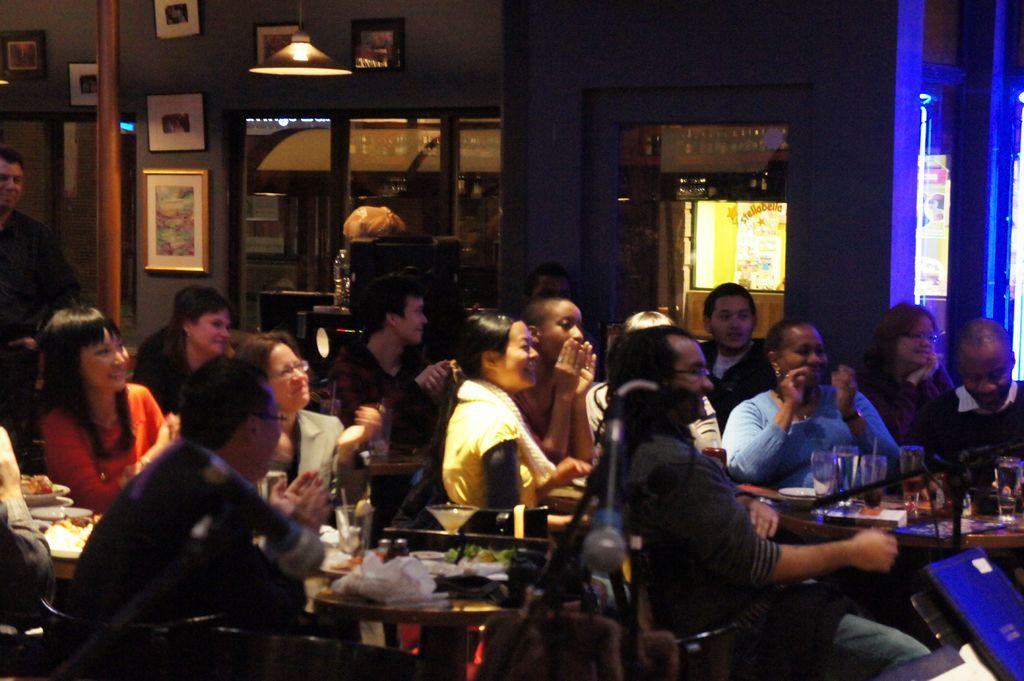How many people are in the image? A: There are persons in the image, but the exact number is not specified. What type of furniture can be seen in the image? There are tables in the image. What objects are used for drinking in the image? There are glasses in the image. Can you describe the background of the image? In the background of the image, there is a wall, frames, a pole, glass windows, a light, and other objects. What type of friction can be observed between the persons in the image? There is no information about friction between the persons in the image, as the facts provided do not mention any interactions or movements. What appliance is being used by the persons in the image? There is no appliance visible in the image, as the facts provided only mention the presence of persons, tables, glasses, and various background elements. 